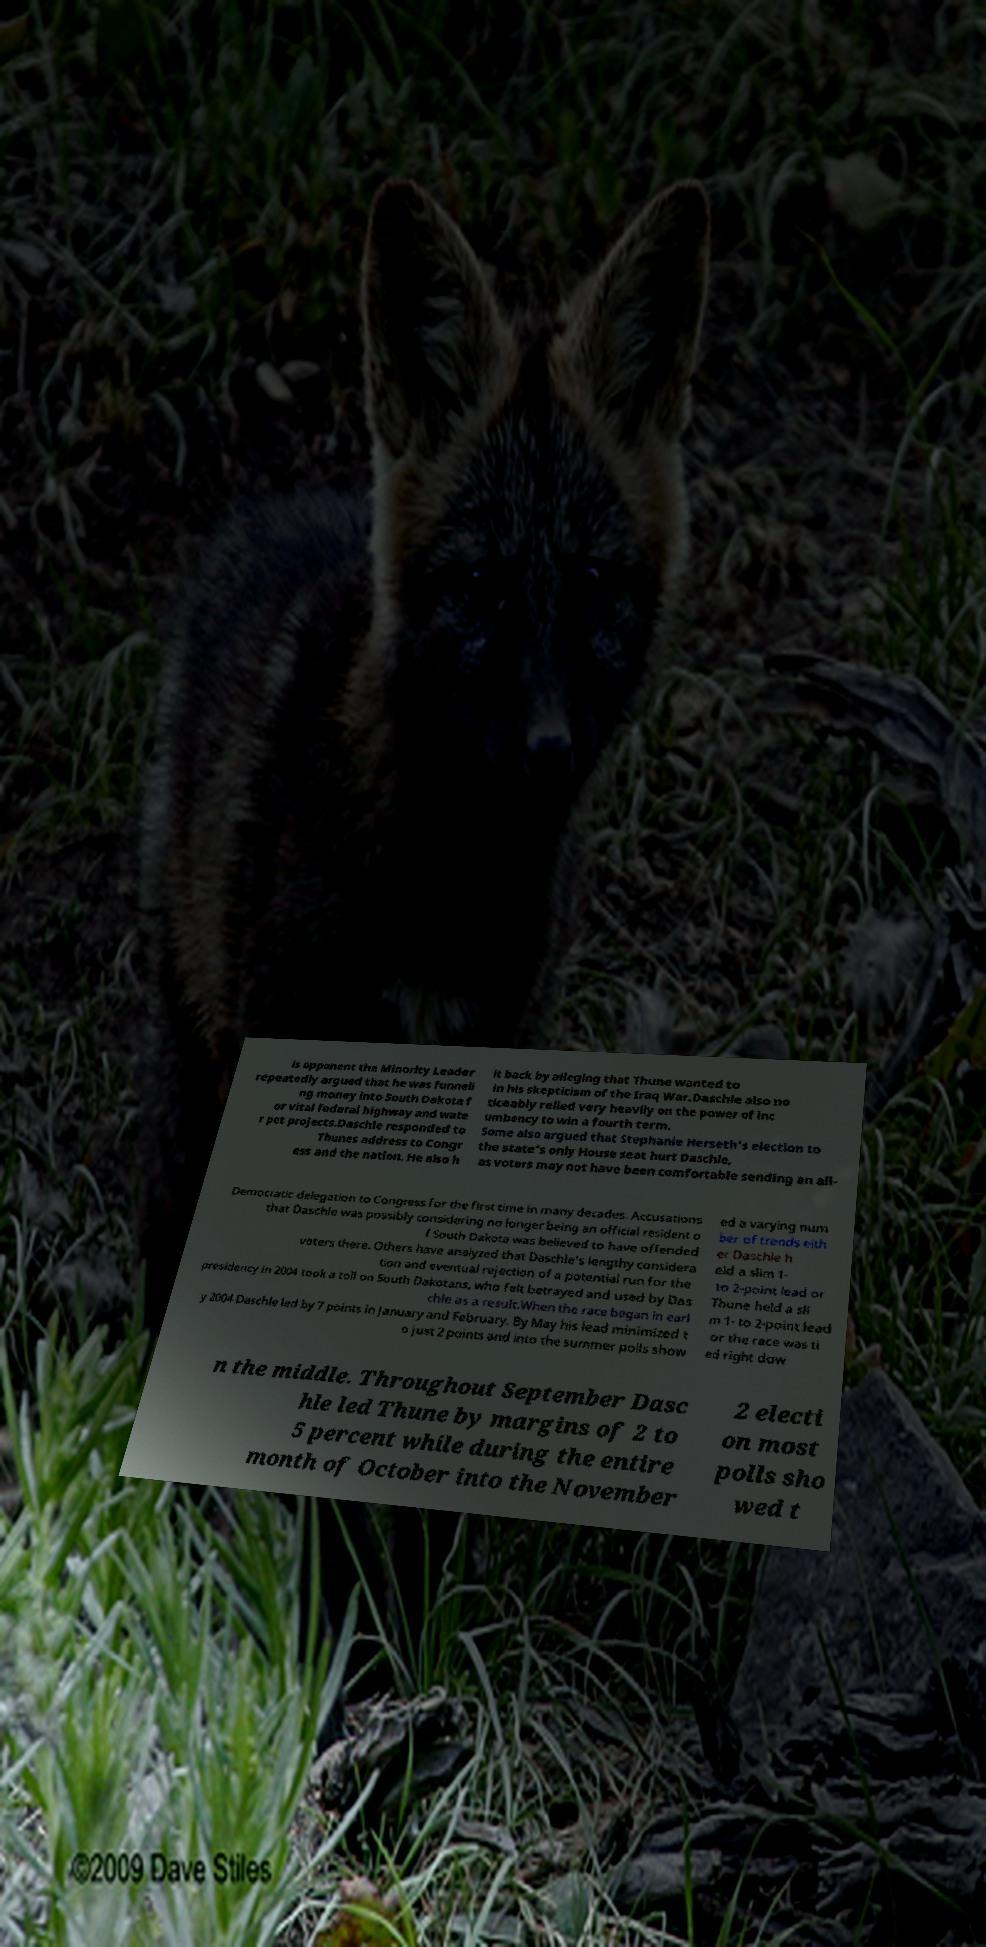Please read and relay the text visible in this image. What does it say? is opponent the Minority Leader repeatedly argued that he was funneli ng money into South Dakota f or vital federal highway and wate r pet projects.Daschle responded to Thunes address to Congr ess and the nation. He also h it back by alleging that Thune wanted to in his skepticism of the Iraq War.Daschle also no ticeably relied very heavily on the power of inc umbency to win a fourth term. Some also argued that Stephanie Herseth's election to the state's only House seat hurt Daschle, as voters may not have been comfortable sending an all- Democratic delegation to Congress for the first time in many decades. Accusations that Daschle was possibly considering no longer being an official resident o f South Dakota was believed to have offended voters there. Others have analyzed that Daschle's lengthy considera tion and eventual rejection of a potential run for the presidency in 2004 took a toll on South Dakotans, who felt betrayed and used by Das chle as a result.When the race began in earl y 2004 Daschle led by 7 points in January and February. By May his lead minimized t o just 2 points and into the summer polls show ed a varying num ber of trends eith er Daschle h eld a slim 1- to 2-point lead or Thune held a sli m 1- to 2-point lead or the race was ti ed right dow n the middle. Throughout September Dasc hle led Thune by margins of 2 to 5 percent while during the entire month of October into the November 2 electi on most polls sho wed t 